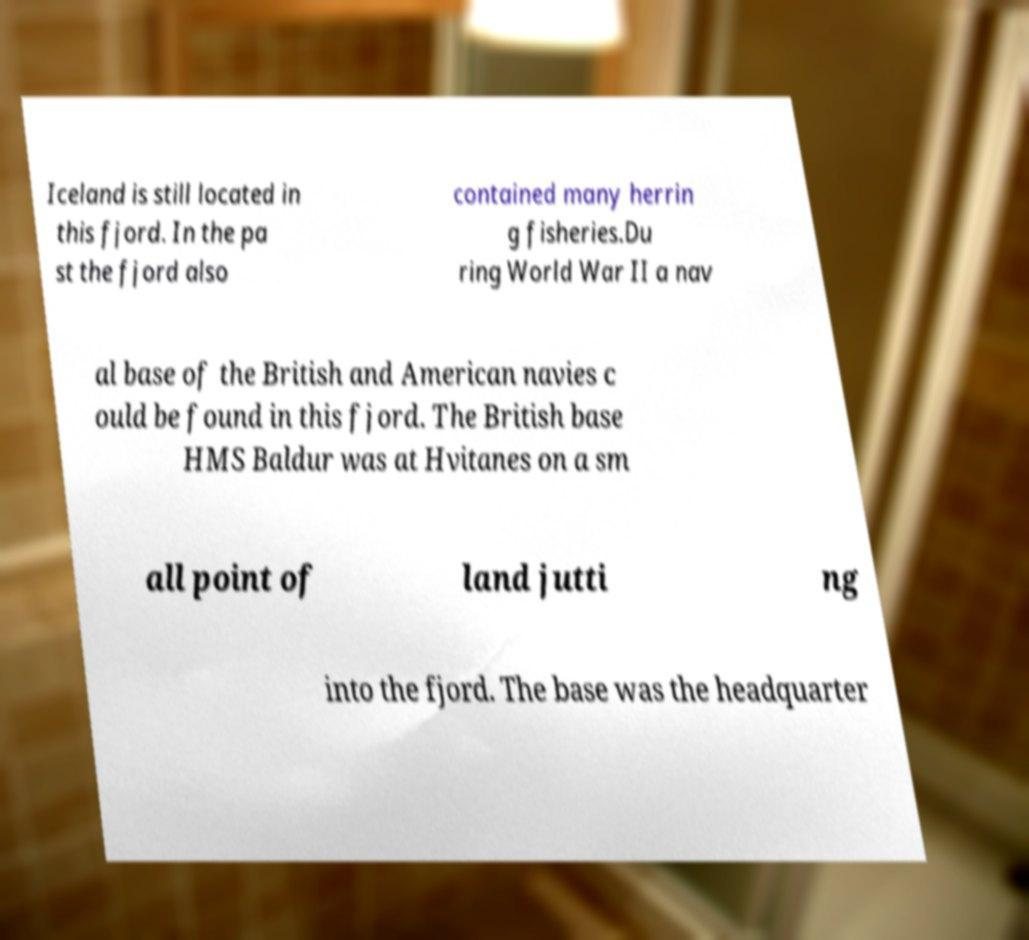Can you accurately transcribe the text from the provided image for me? Iceland is still located in this fjord. In the pa st the fjord also contained many herrin g fisheries.Du ring World War II a nav al base of the British and American navies c ould be found in this fjord. The British base HMS Baldur was at Hvitanes on a sm all point of land jutti ng into the fjord. The base was the headquarter 